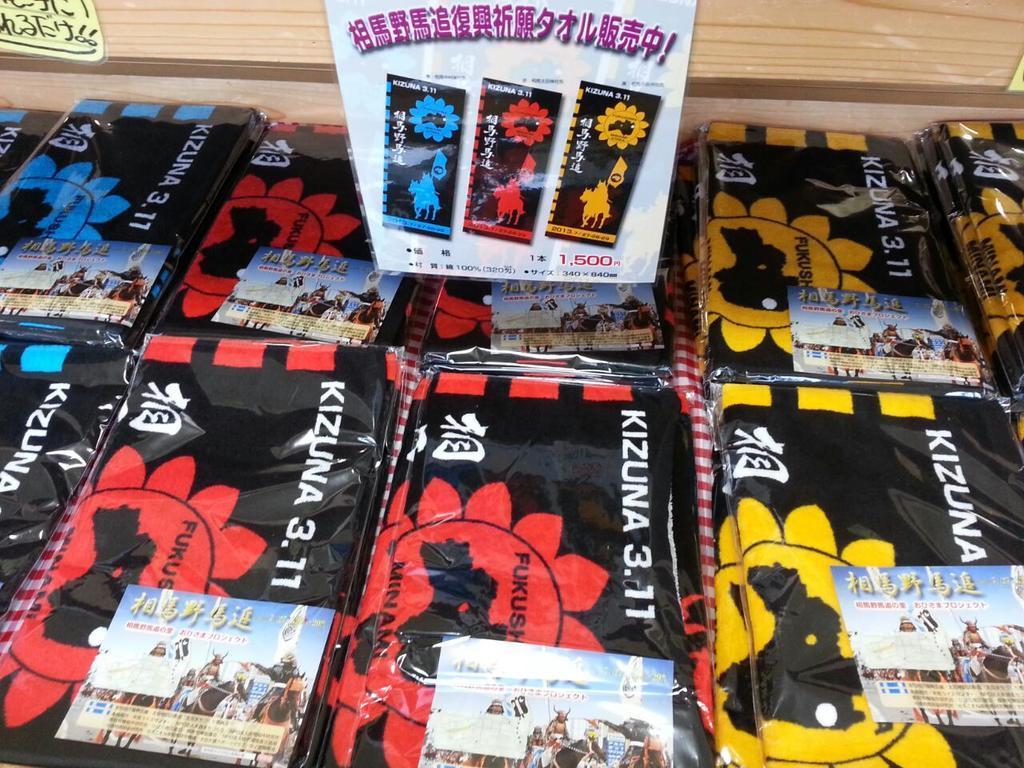Can you describe this image briefly? In the foreground of the picture there are some covers in blue, yellow, red and black colors they might be book covers. At the top there is a wooden object. 